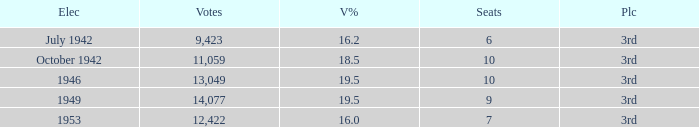Name the sum of votes % more than 19.5 None. 